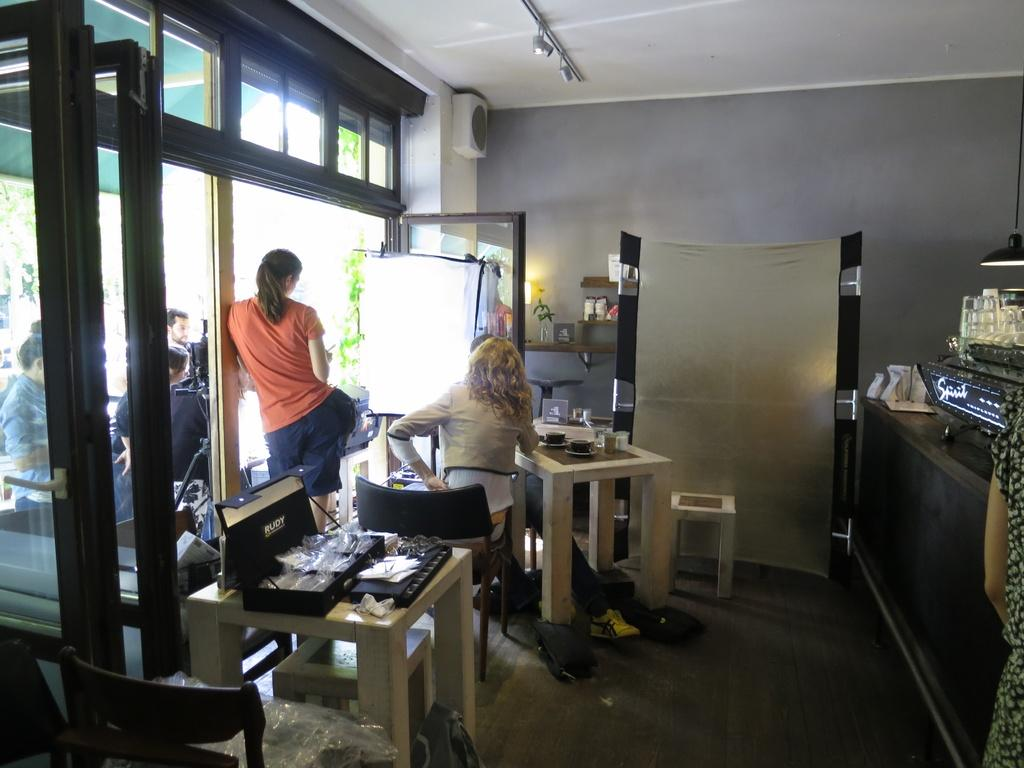How many people are in the image? There is a group of people in the image. What are the people doing in the image? Some people are standing, while others are seated on chairs. What can be found on the table in the image? There are objects on the table, including tea cups. What is visible in the background of the image? There are trees visible in the image. What type of flower is being worn by the person in the image? There is no flower visible on any person in the image. What scene is being depicted in the image? The image does not depict a specific scene; it simply shows a group of people, some standing and others seated, with objects on a table and trees in the background. 